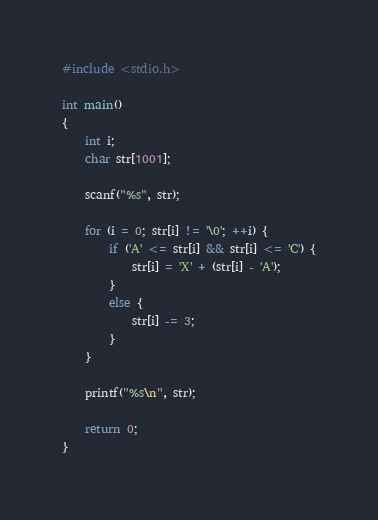Convert code to text. <code><loc_0><loc_0><loc_500><loc_500><_C_>#include <stdio.h>

int main()
{
	int i;
	char str[1001];

	scanf("%s", str);

	for (i = 0; str[i] != '\0'; ++i) {
		if ('A' <= str[i] && str[i] <= 'C') {
			str[i] = 'X' + (str[i] - 'A');
		}
		else {
			str[i] -= 3;
		}
	}

	printf("%s\n", str);

	return 0;
}</code> 